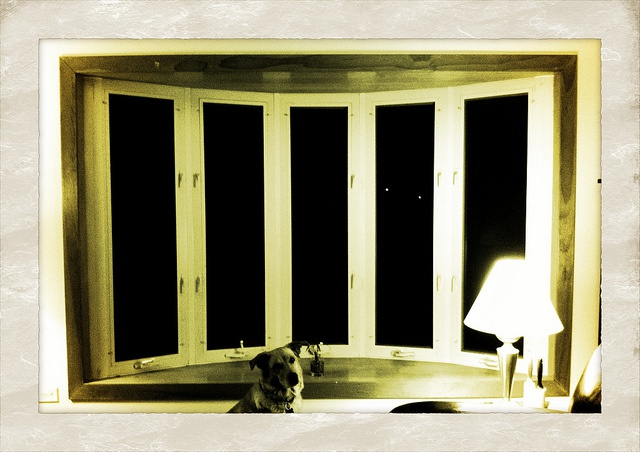Describe the objects in this image and their specific colors. I can see a dog in tan, black, darkgreen, khaki, and olive tones in this image. 